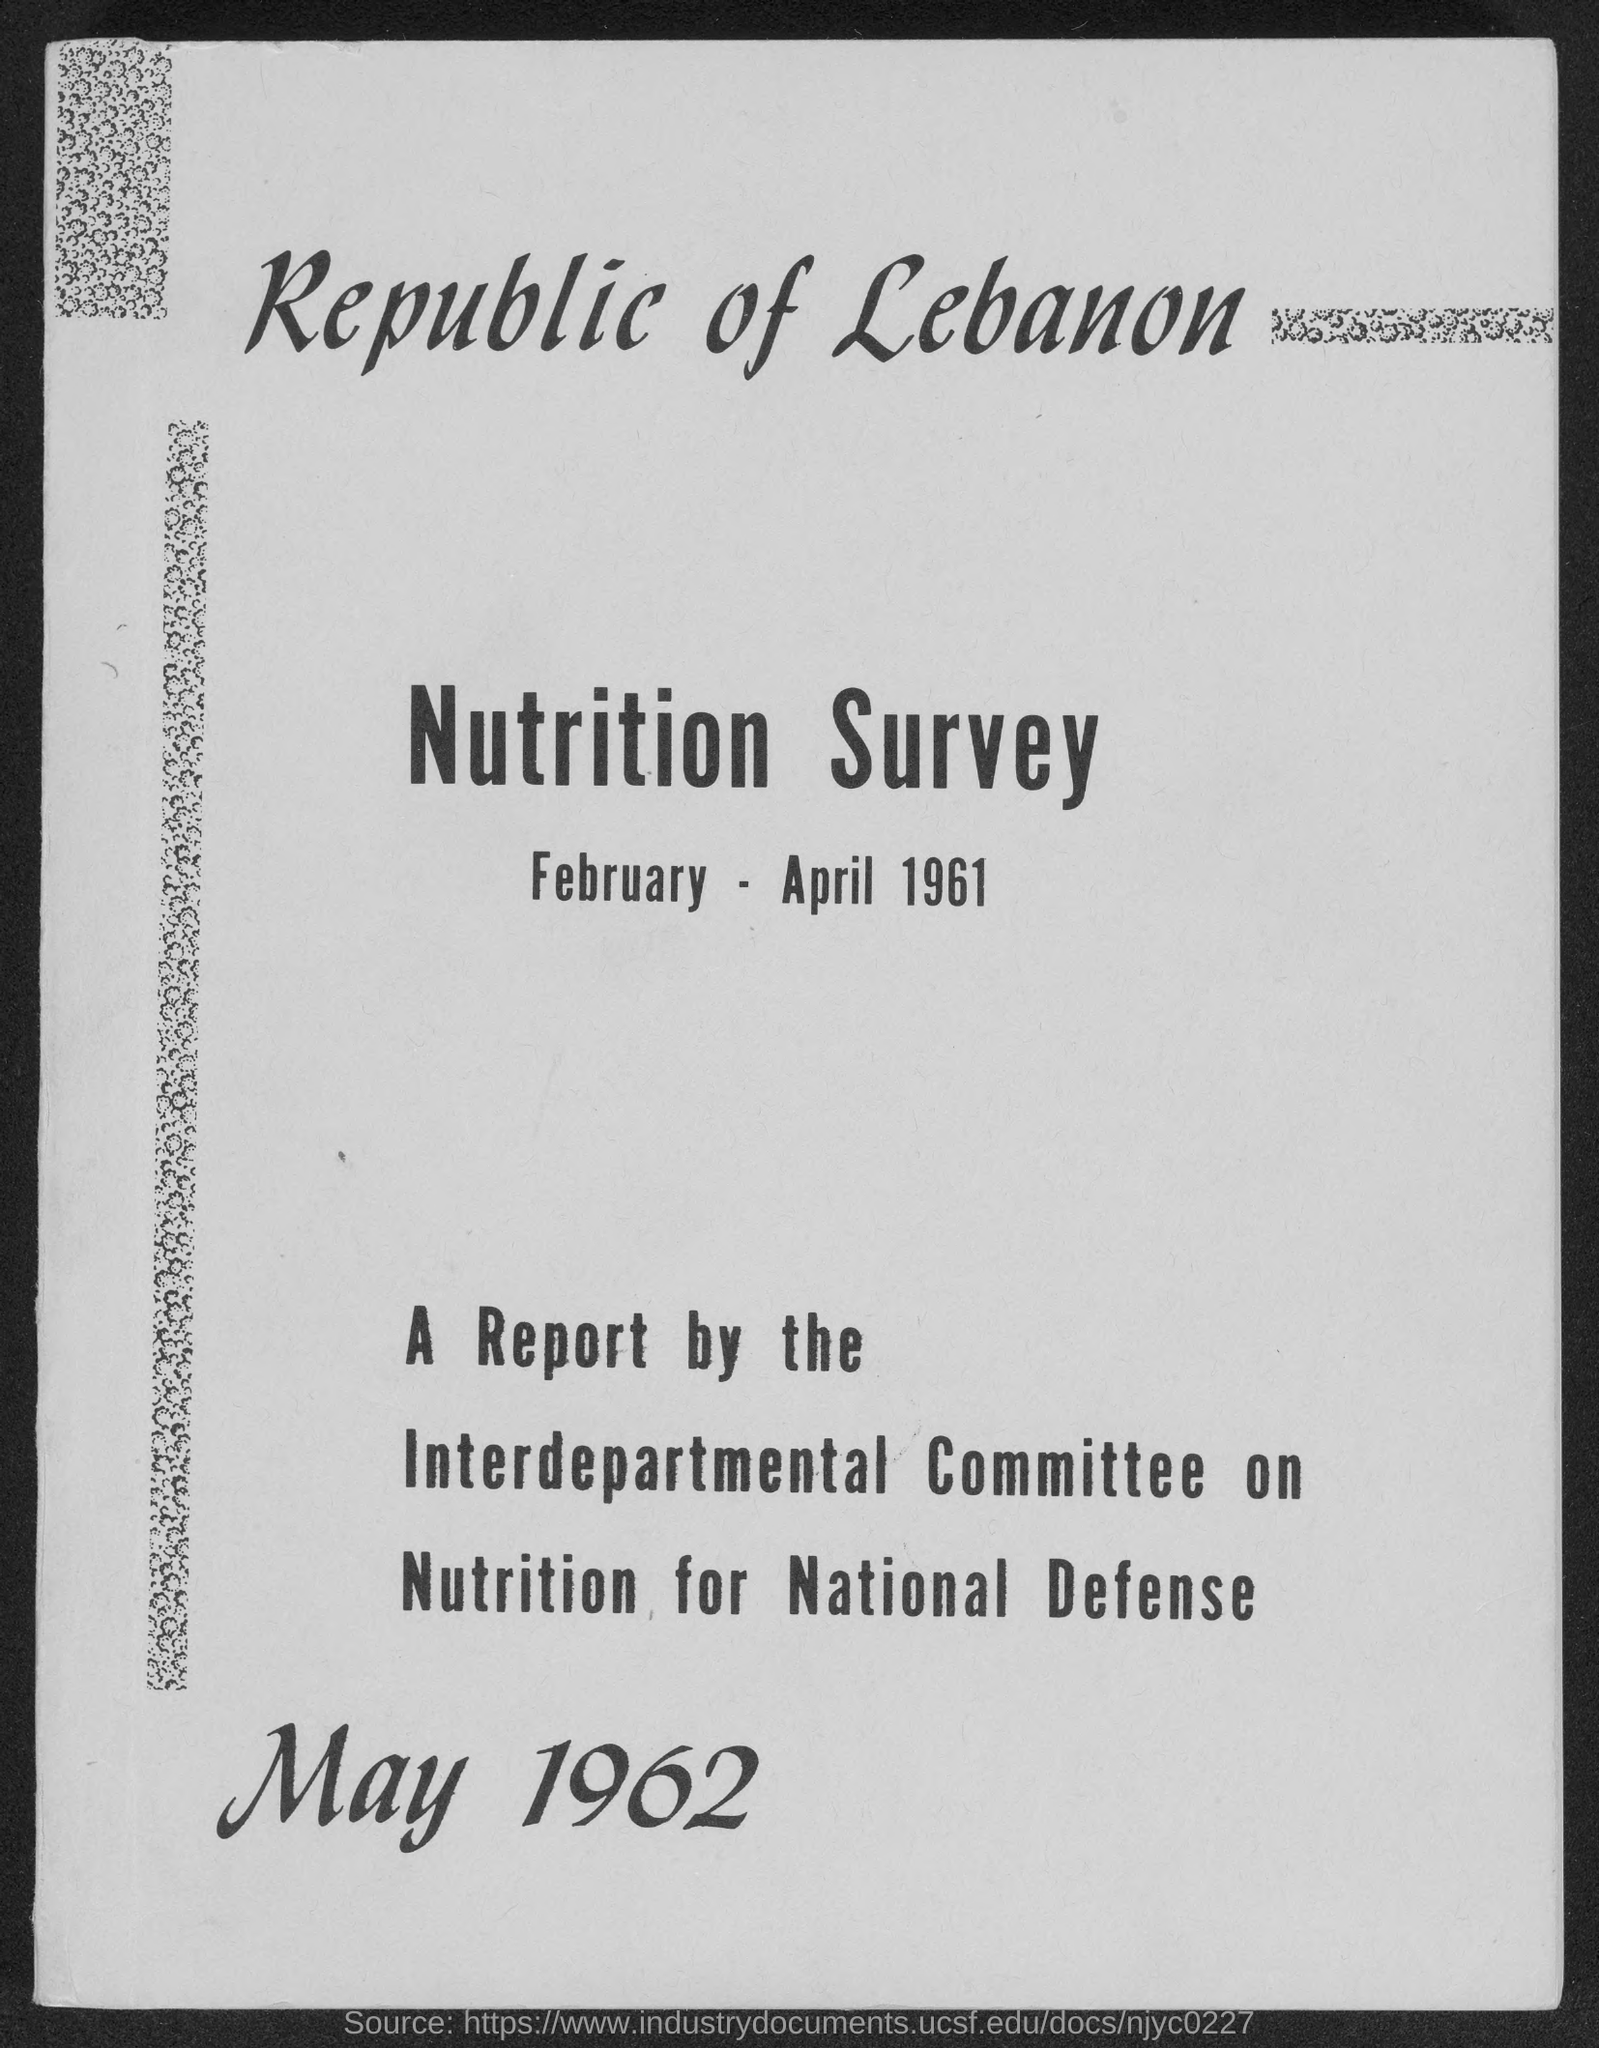What is the first title in the document?
Provide a succinct answer. Republic of Lebanon. What is the second title in the document?
Offer a very short reply. Nutrition survey. What is the date mentioned at the bottom of the document?
Give a very brief answer. May 1962. The report is prepared by whom?
Make the answer very short. Interdepartmental committee on nutrition for national defense. 